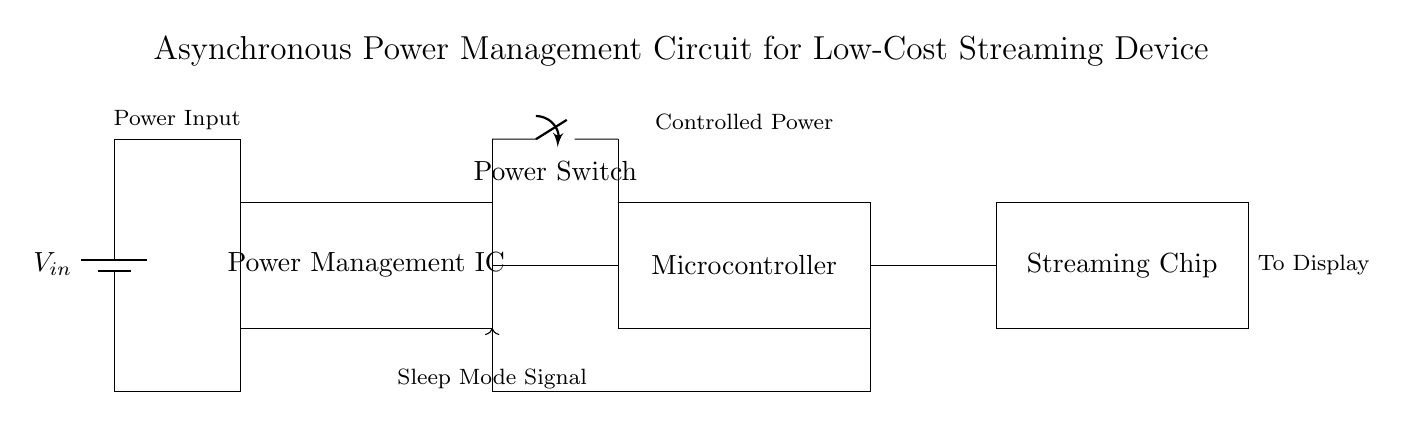What is the main function of the Power Management IC? The Power Management IC controls the power distribution to various components of the circuit, ensuring efficient operation and minimizing energy waste.
Answer: control power distribution What type of device is the microcontroller in this circuit? The microcontroller in the circuit is a digital device that processes signals and controls other components based on input data, making it essential for device functionality.
Answer: digital device How many major components are in the circuit? The circuit contains three major components: the Power Management IC, the Microcontroller, and the Streaming Chip.
Answer: three What does the Sleep Mode Signal indicate? The Sleep Mode Signal indicates when the device should enter a low-power state to conserve energy, which is crucial for minimizing electricity consumption.
Answer: energy conservation What does the power switch do in this circuit? The power switch controls the flow of electricity from the power supply to the power management IC, allowing the user to turn the device on or off as needed.
Answer: control power flow Why is it important for the streaming device to minimize electricity consumption? Minimizing electricity consumption is important for reducing operational costs and increasing the longevity of the device, making it more economical for users.
Answer: reduce costs Which component is directly connected to the display? The Streaming Chip is directly connected to the display, sending the processed streaming data to be shown.
Answer: Streaming Chip 